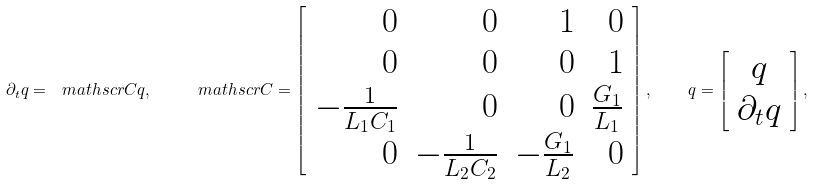Convert formula to latex. <formula><loc_0><loc_0><loc_500><loc_500>\partial _ { t } q = \ m a t h s c r { C } q , \quad \ m a t h s c r { C } = \left [ \begin{array} { r r r r } 0 & 0 & 1 & 0 \\ 0 & 0 & 0 & 1 \\ - \frac { 1 } { L _ { 1 } C _ { 1 } } & 0 & 0 & \frac { G _ { 1 } } { L _ { 1 } } \\ 0 & - \frac { 1 } { L _ { 2 } C _ { 2 } } & - \frac { G _ { 1 } } { L _ { 2 } } & 0 \end{array} \right ] , \quad q = \left [ \begin{array} { c } q \\ \partial _ { t } q \end{array} \right ] ,</formula> 